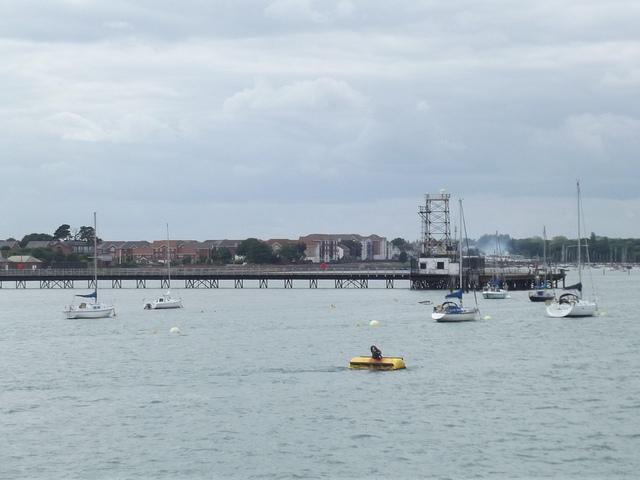What do many of the boats shown here normally use but lack here?
Answer the question by selecting the correct answer among the 4 following choices and explain your choice with a short sentence. The answer should be formatted with the following format: `Answer: choice
Rationale: rationale.`
Options: Pirates, sails, steam shovels, motors. Answer: sails.
Rationale: There are many sailboats. 